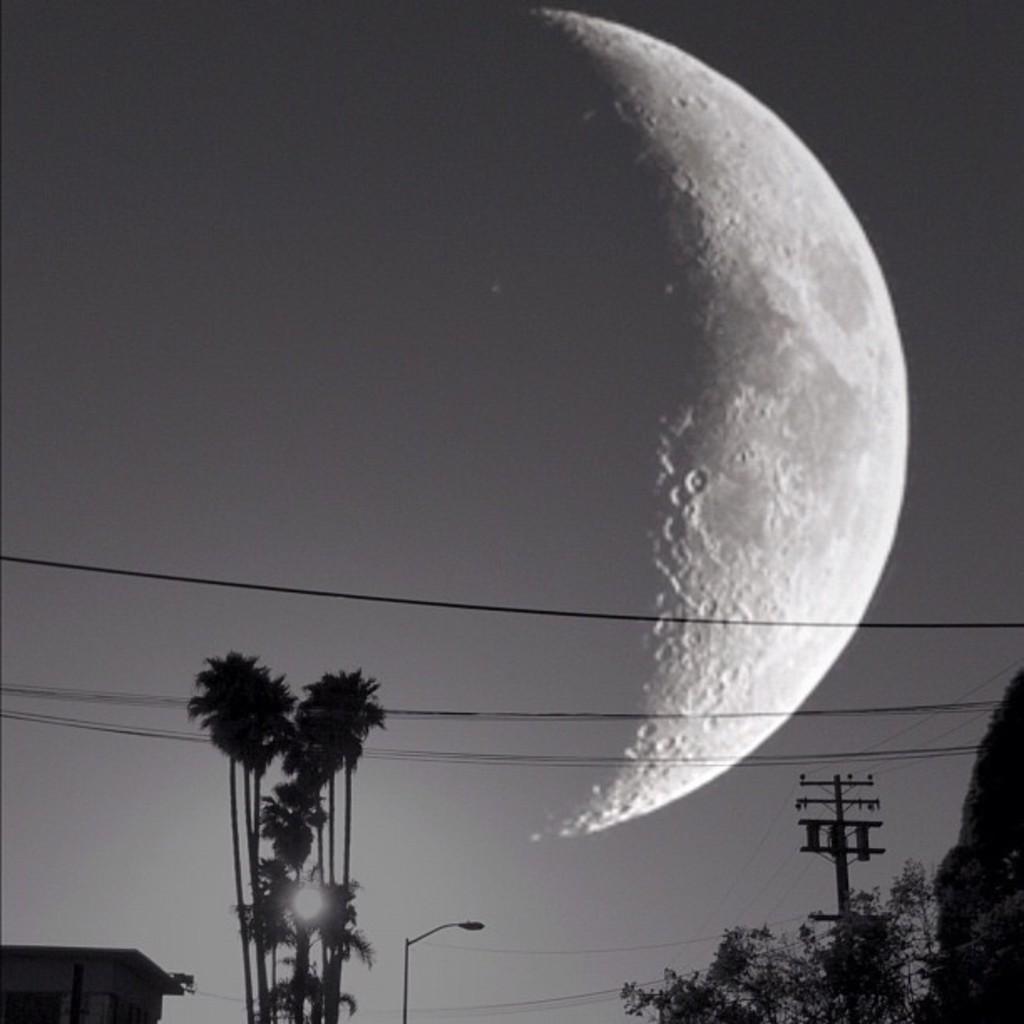How would you summarize this image in a sentence or two? This is a black and white pic. At the bottom we can see trees, street light, pole, wires and objects. In the background we can see moon in the sky. 